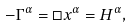<formula> <loc_0><loc_0><loc_500><loc_500>- \Gamma ^ { \alpha } = \Box x ^ { \alpha } = H ^ { \alpha } ,</formula> 